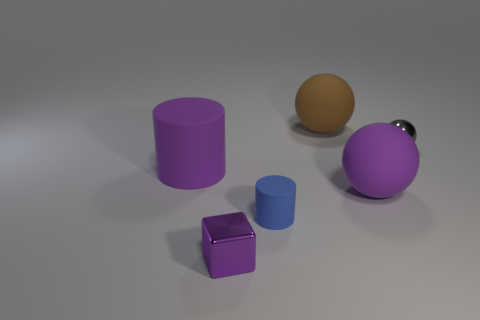There is a metallic sphere; is it the same color as the object that is in front of the small blue object?
Provide a short and direct response. No. What number of cyan things are either cylinders or balls?
Offer a terse response. 0. What is the shape of the purple metallic object?
Your answer should be compact. Cube. What number of other things are the same shape as the gray metallic object?
Make the answer very short. 2. There is a tiny metallic thing on the left side of the big brown matte sphere; what is its color?
Your response must be concise. Purple. Is the big cylinder made of the same material as the gray sphere?
Your response must be concise. No. How many things are either small blue matte cylinders or big things that are in front of the big brown rubber object?
Make the answer very short. 3. There is a rubber ball that is the same color as the metallic cube; what is its size?
Your response must be concise. Large. What shape is the purple thing to the right of the brown rubber sphere?
Keep it short and to the point. Sphere. There is a rubber object that is on the left side of the tiny cylinder; is it the same color as the tiny rubber thing?
Your response must be concise. No. 